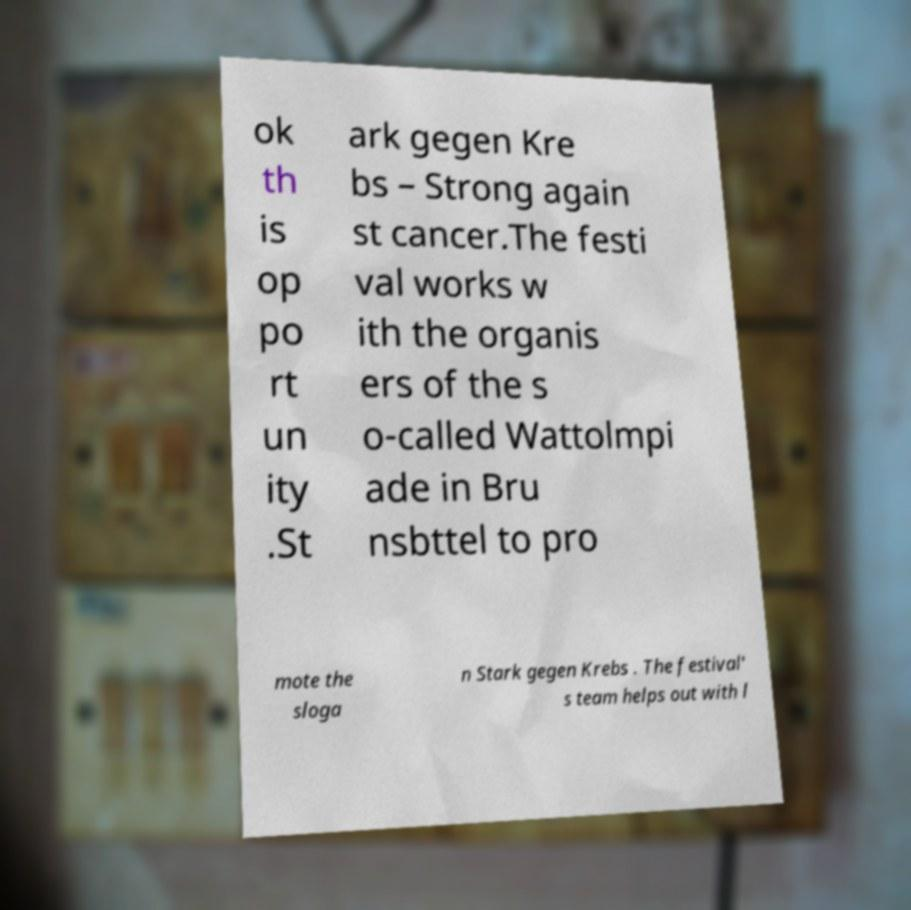For documentation purposes, I need the text within this image transcribed. Could you provide that? ok th is op po rt un ity .St ark gegen Kre bs – Strong again st cancer.The festi val works w ith the organis ers of the s o-called Wattolmpi ade in Bru nsbttel to pro mote the sloga n Stark gegen Krebs . The festival' s team helps out with l 